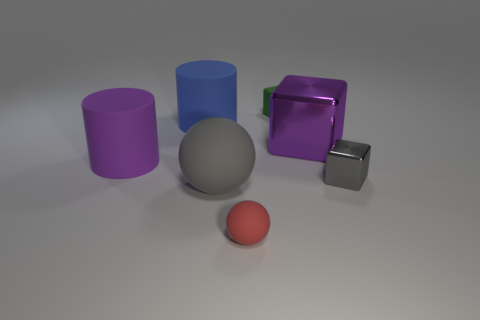The purple rubber thing is what size?
Give a very brief answer. Large. How many gray things are either small balls or tiny blocks?
Provide a short and direct response. 1. There is a cylinder that is on the left side of the big blue cylinder left of the small gray metallic thing; what is its size?
Provide a succinct answer. Large. There is a large metallic thing; is its color the same as the large matte object that is in front of the tiny metallic object?
Provide a short and direct response. No. How many other things are there of the same material as the large blue thing?
Your answer should be very brief. 4. The big thing that is the same material as the gray cube is what shape?
Your response must be concise. Cube. Is there anything else of the same color as the small sphere?
Provide a short and direct response. No. There is a object that is the same color as the big matte sphere; what size is it?
Your answer should be compact. Small. Is the number of blue cylinders that are behind the gray ball greater than the number of tiny gray metal objects?
Keep it short and to the point. No. There is a blue rubber thing; is its shape the same as the small object behind the purple cylinder?
Your response must be concise. No. 